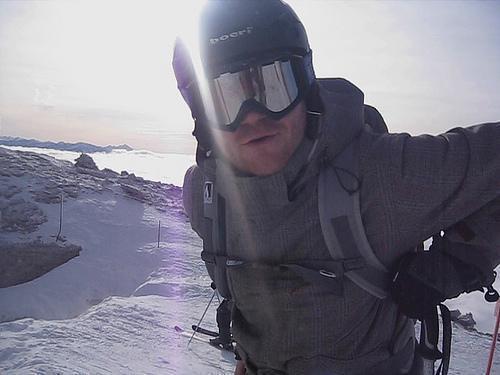What nationality were the founders of this helmet company?
Select the accurate response from the four choices given to answer the question.
Options: Italian, swiss, french, russian. Italian. 